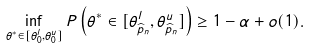<formula> <loc_0><loc_0><loc_500><loc_500>\inf _ { \theta ^ { * } \in [ \theta _ { 0 } ^ { l } , \theta _ { 0 } ^ { u } ] } P \left ( \theta ^ { * } \in [ \theta _ { \widehat { p } _ { n } } ^ { l } , \theta _ { \widehat { p } _ { n } } ^ { u } ] \right ) \geq 1 - \alpha + o ( 1 ) .</formula> 